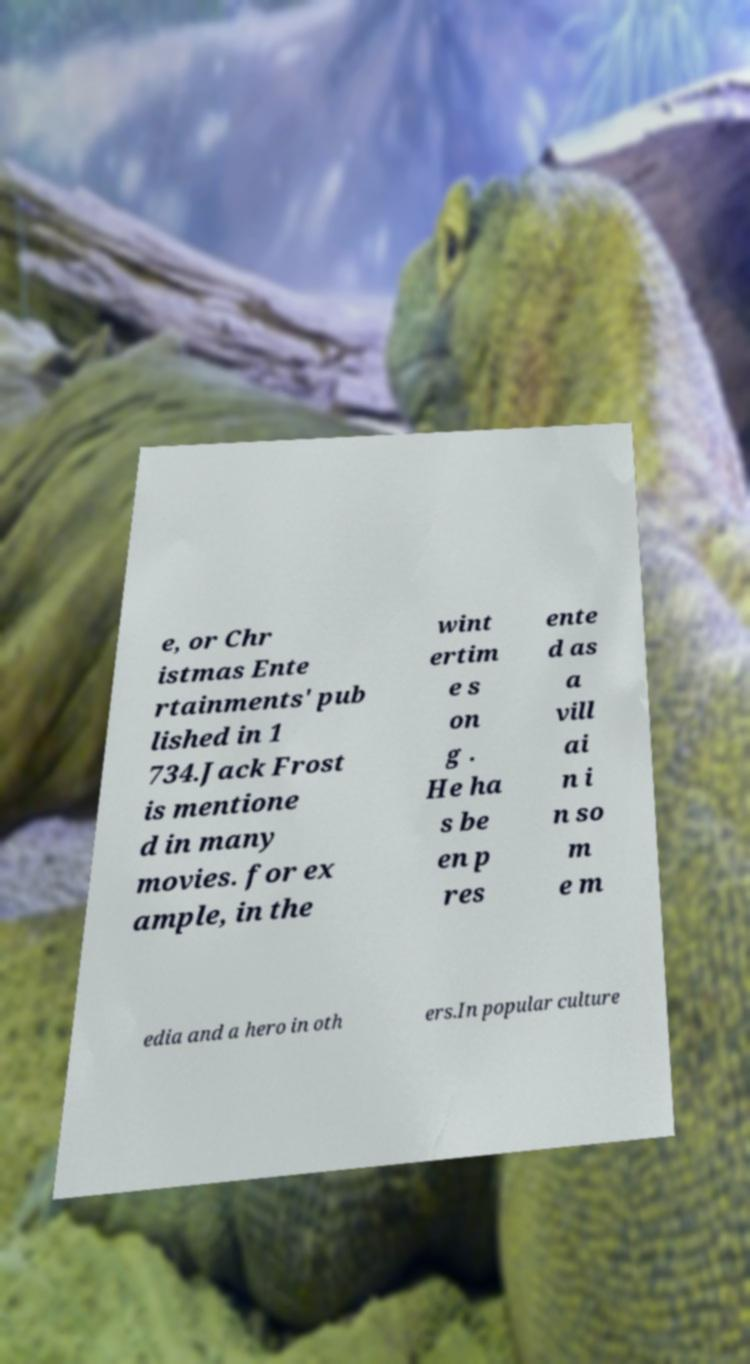Could you extract and type out the text from this image? e, or Chr istmas Ente rtainments' pub lished in 1 734.Jack Frost is mentione d in many movies. for ex ample, in the wint ertim e s on g . He ha s be en p res ente d as a vill ai n i n so m e m edia and a hero in oth ers.In popular culture 